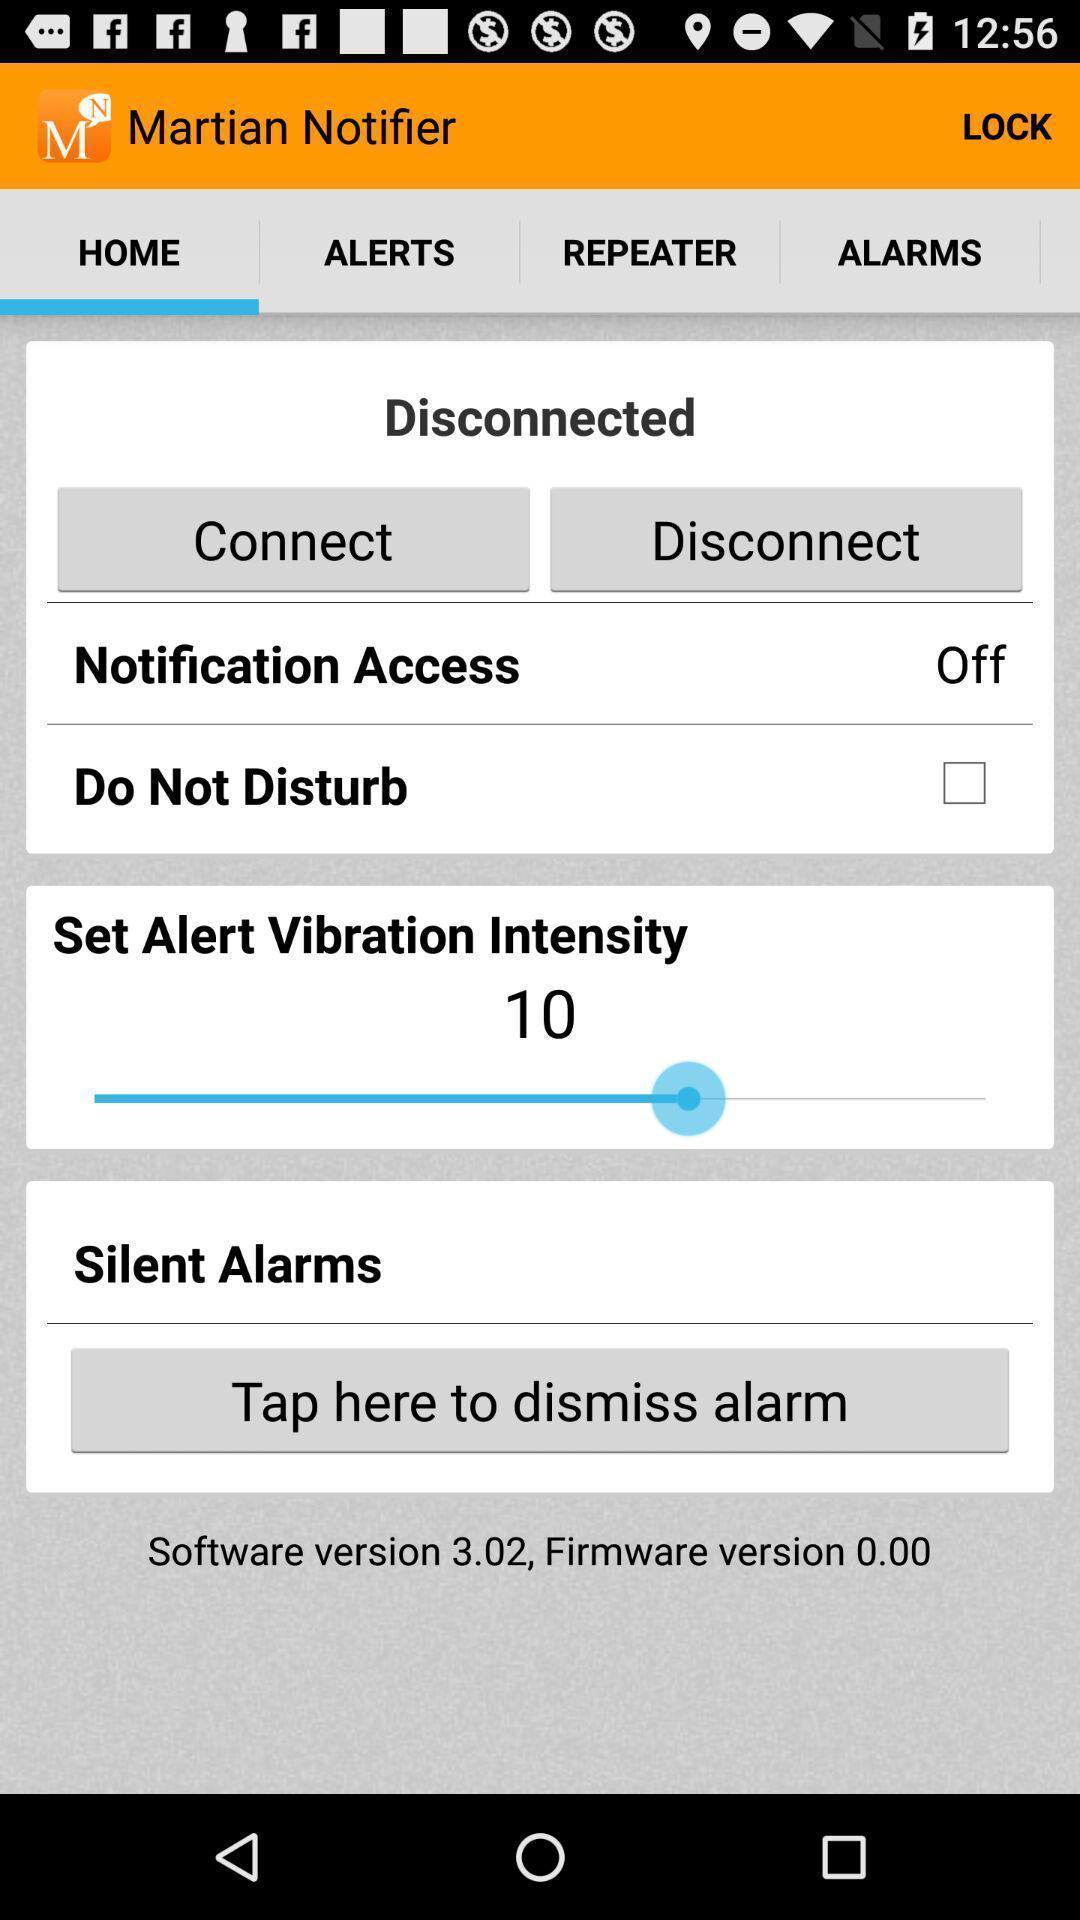Describe the key features of this screenshot. Page displaying the notification vibration intensity. 